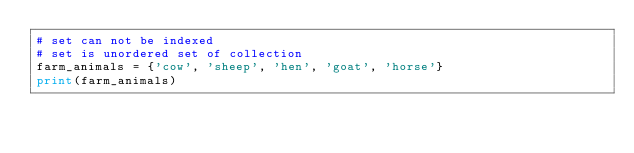Convert code to text. <code><loc_0><loc_0><loc_500><loc_500><_Python_># set can not be indexed
# set is unordered set of collection
farm_animals = {'cow', 'sheep', 'hen', 'goat', 'horse'}
print(farm_animals)
</code> 